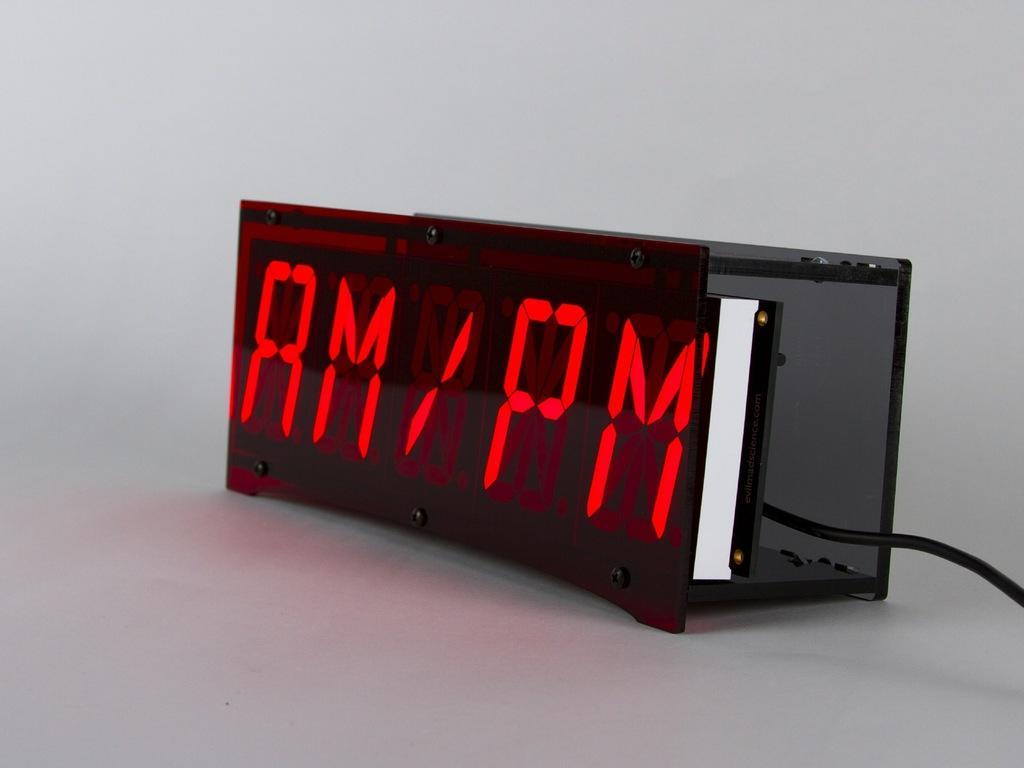How would you summarize this image in a sentence or two? In the middle of the image we can see a digital display and a cable. 